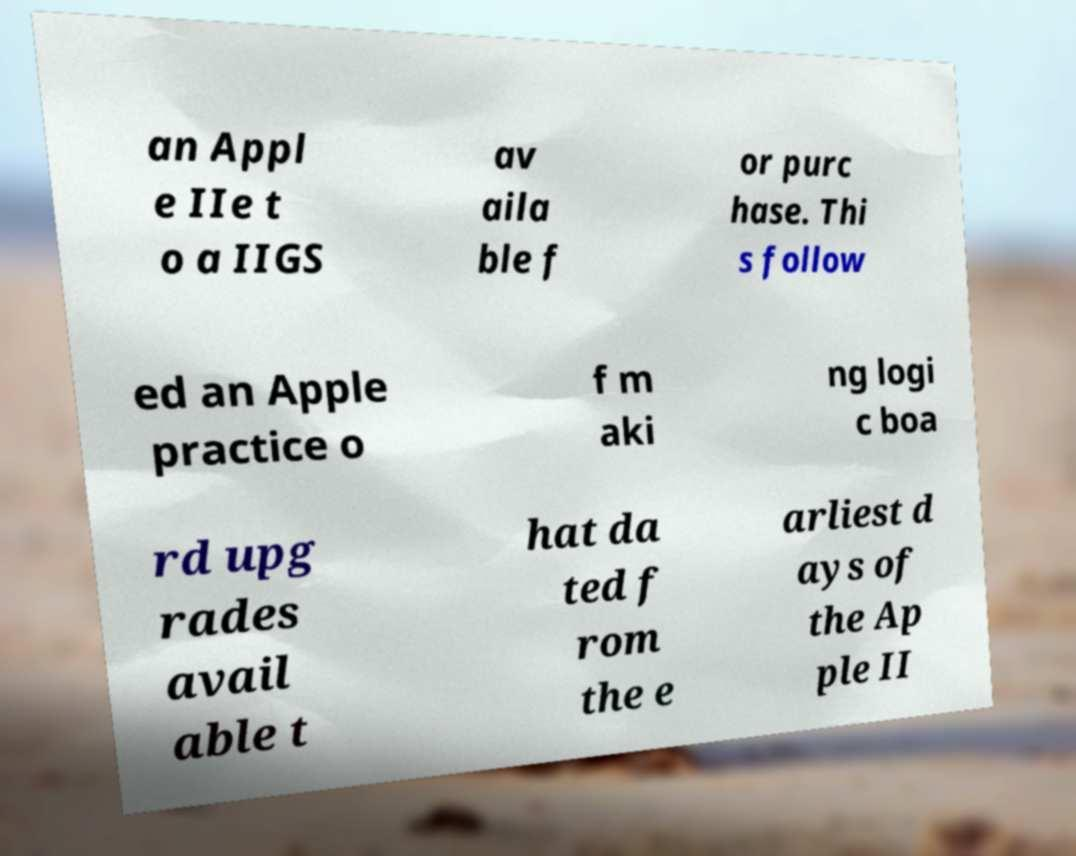I need the written content from this picture converted into text. Can you do that? an Appl e IIe t o a IIGS av aila ble f or purc hase. Thi s follow ed an Apple practice o f m aki ng logi c boa rd upg rades avail able t hat da ted f rom the e arliest d ays of the Ap ple II 